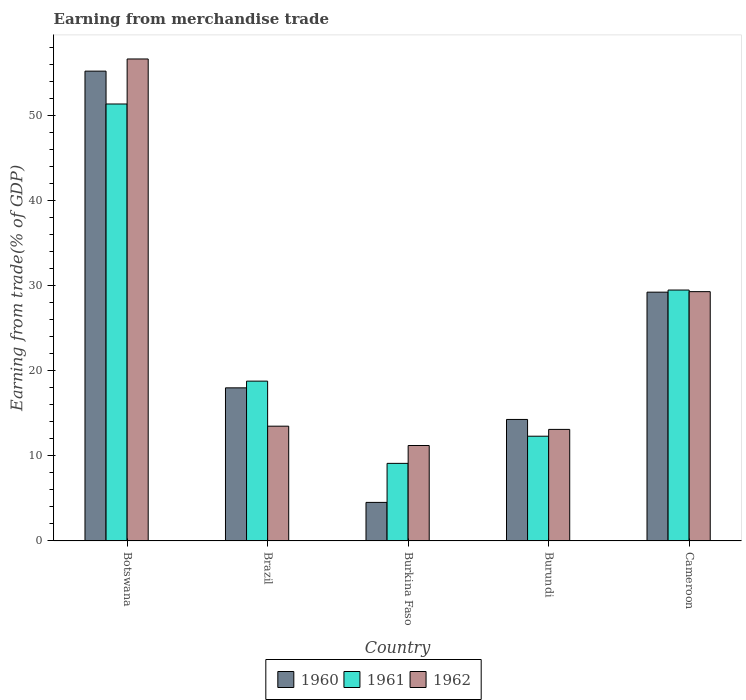Are the number of bars per tick equal to the number of legend labels?
Your answer should be compact. Yes. What is the label of the 2nd group of bars from the left?
Provide a short and direct response. Brazil. What is the earnings from trade in 1961 in Brazil?
Ensure brevity in your answer.  18.79. Across all countries, what is the maximum earnings from trade in 1962?
Keep it short and to the point. 56.67. Across all countries, what is the minimum earnings from trade in 1962?
Offer a very short reply. 11.22. In which country was the earnings from trade in 1960 maximum?
Keep it short and to the point. Botswana. In which country was the earnings from trade in 1961 minimum?
Offer a very short reply. Burkina Faso. What is the total earnings from trade in 1960 in the graph?
Your answer should be compact. 121.31. What is the difference between the earnings from trade in 1962 in Brazil and that in Burkina Faso?
Provide a succinct answer. 2.27. What is the difference between the earnings from trade in 1961 in Burkina Faso and the earnings from trade in 1960 in Brazil?
Your response must be concise. -8.88. What is the average earnings from trade in 1962 per country?
Ensure brevity in your answer.  24.76. What is the difference between the earnings from trade of/in 1962 and earnings from trade of/in 1960 in Burkina Faso?
Offer a terse response. 6.69. What is the ratio of the earnings from trade in 1962 in Botswana to that in Cameroon?
Your answer should be compact. 1.93. Is the earnings from trade in 1962 in Botswana less than that in Burkina Faso?
Keep it short and to the point. No. What is the difference between the highest and the second highest earnings from trade in 1960?
Give a very brief answer. -11.25. What is the difference between the highest and the lowest earnings from trade in 1961?
Offer a very short reply. 42.26. What does the 3rd bar from the right in Botswana represents?
Make the answer very short. 1960. How many bars are there?
Make the answer very short. 15. How many countries are there in the graph?
Ensure brevity in your answer.  5. Where does the legend appear in the graph?
Offer a terse response. Bottom center. How many legend labels are there?
Offer a terse response. 3. What is the title of the graph?
Provide a succinct answer. Earning from merchandise trade. Does "1996" appear as one of the legend labels in the graph?
Offer a very short reply. No. What is the label or title of the X-axis?
Ensure brevity in your answer.  Country. What is the label or title of the Y-axis?
Your answer should be very brief. Earning from trade(% of GDP). What is the Earning from trade(% of GDP) of 1960 in Botswana?
Your answer should be very brief. 55.24. What is the Earning from trade(% of GDP) in 1961 in Botswana?
Give a very brief answer. 51.38. What is the Earning from trade(% of GDP) of 1962 in Botswana?
Ensure brevity in your answer.  56.67. What is the Earning from trade(% of GDP) of 1960 in Brazil?
Offer a terse response. 18. What is the Earning from trade(% of GDP) in 1961 in Brazil?
Your response must be concise. 18.79. What is the Earning from trade(% of GDP) of 1962 in Brazil?
Your answer should be compact. 13.49. What is the Earning from trade(% of GDP) in 1960 in Burkina Faso?
Offer a terse response. 4.53. What is the Earning from trade(% of GDP) of 1961 in Burkina Faso?
Your answer should be very brief. 9.12. What is the Earning from trade(% of GDP) in 1962 in Burkina Faso?
Offer a very short reply. 11.22. What is the Earning from trade(% of GDP) in 1960 in Burundi?
Provide a succinct answer. 14.29. What is the Earning from trade(% of GDP) of 1961 in Burundi?
Your response must be concise. 12.32. What is the Earning from trade(% of GDP) in 1962 in Burundi?
Provide a short and direct response. 13.11. What is the Earning from trade(% of GDP) in 1960 in Cameroon?
Offer a terse response. 29.25. What is the Earning from trade(% of GDP) in 1961 in Cameroon?
Offer a very short reply. 29.5. What is the Earning from trade(% of GDP) in 1962 in Cameroon?
Give a very brief answer. 29.31. Across all countries, what is the maximum Earning from trade(% of GDP) of 1960?
Give a very brief answer. 55.24. Across all countries, what is the maximum Earning from trade(% of GDP) of 1961?
Your answer should be compact. 51.38. Across all countries, what is the maximum Earning from trade(% of GDP) in 1962?
Keep it short and to the point. 56.67. Across all countries, what is the minimum Earning from trade(% of GDP) of 1960?
Provide a succinct answer. 4.53. Across all countries, what is the minimum Earning from trade(% of GDP) in 1961?
Offer a terse response. 9.12. Across all countries, what is the minimum Earning from trade(% of GDP) in 1962?
Give a very brief answer. 11.22. What is the total Earning from trade(% of GDP) of 1960 in the graph?
Your answer should be very brief. 121.31. What is the total Earning from trade(% of GDP) in 1961 in the graph?
Your answer should be compact. 121.11. What is the total Earning from trade(% of GDP) of 1962 in the graph?
Offer a terse response. 123.81. What is the difference between the Earning from trade(% of GDP) in 1960 in Botswana and that in Brazil?
Provide a short and direct response. 37.24. What is the difference between the Earning from trade(% of GDP) of 1961 in Botswana and that in Brazil?
Provide a succinct answer. 32.59. What is the difference between the Earning from trade(% of GDP) of 1962 in Botswana and that in Brazil?
Offer a terse response. 43.18. What is the difference between the Earning from trade(% of GDP) in 1960 in Botswana and that in Burkina Faso?
Your answer should be compact. 50.71. What is the difference between the Earning from trade(% of GDP) of 1961 in Botswana and that in Burkina Faso?
Give a very brief answer. 42.26. What is the difference between the Earning from trade(% of GDP) of 1962 in Botswana and that in Burkina Faso?
Provide a short and direct response. 45.45. What is the difference between the Earning from trade(% of GDP) of 1960 in Botswana and that in Burundi?
Provide a succinct answer. 40.96. What is the difference between the Earning from trade(% of GDP) in 1961 in Botswana and that in Burundi?
Provide a succinct answer. 39.06. What is the difference between the Earning from trade(% of GDP) in 1962 in Botswana and that in Burundi?
Ensure brevity in your answer.  43.56. What is the difference between the Earning from trade(% of GDP) in 1960 in Botswana and that in Cameroon?
Offer a terse response. 25.99. What is the difference between the Earning from trade(% of GDP) in 1961 in Botswana and that in Cameroon?
Provide a succinct answer. 21.88. What is the difference between the Earning from trade(% of GDP) of 1962 in Botswana and that in Cameroon?
Make the answer very short. 27.36. What is the difference between the Earning from trade(% of GDP) of 1960 in Brazil and that in Burkina Faso?
Provide a short and direct response. 13.47. What is the difference between the Earning from trade(% of GDP) of 1961 in Brazil and that in Burkina Faso?
Your answer should be very brief. 9.67. What is the difference between the Earning from trade(% of GDP) of 1962 in Brazil and that in Burkina Faso?
Offer a terse response. 2.27. What is the difference between the Earning from trade(% of GDP) in 1960 in Brazil and that in Burundi?
Your response must be concise. 3.72. What is the difference between the Earning from trade(% of GDP) in 1961 in Brazil and that in Burundi?
Provide a short and direct response. 6.47. What is the difference between the Earning from trade(% of GDP) in 1962 in Brazil and that in Burundi?
Your answer should be very brief. 0.38. What is the difference between the Earning from trade(% of GDP) of 1960 in Brazil and that in Cameroon?
Provide a short and direct response. -11.25. What is the difference between the Earning from trade(% of GDP) in 1961 in Brazil and that in Cameroon?
Give a very brief answer. -10.71. What is the difference between the Earning from trade(% of GDP) of 1962 in Brazil and that in Cameroon?
Provide a succinct answer. -15.82. What is the difference between the Earning from trade(% of GDP) of 1960 in Burkina Faso and that in Burundi?
Keep it short and to the point. -9.75. What is the difference between the Earning from trade(% of GDP) in 1961 in Burkina Faso and that in Burundi?
Your response must be concise. -3.19. What is the difference between the Earning from trade(% of GDP) of 1962 in Burkina Faso and that in Burundi?
Your response must be concise. -1.89. What is the difference between the Earning from trade(% of GDP) in 1960 in Burkina Faso and that in Cameroon?
Your answer should be very brief. -24.72. What is the difference between the Earning from trade(% of GDP) of 1961 in Burkina Faso and that in Cameroon?
Make the answer very short. -20.38. What is the difference between the Earning from trade(% of GDP) of 1962 in Burkina Faso and that in Cameroon?
Make the answer very short. -18.09. What is the difference between the Earning from trade(% of GDP) of 1960 in Burundi and that in Cameroon?
Give a very brief answer. -14.97. What is the difference between the Earning from trade(% of GDP) of 1961 in Burundi and that in Cameroon?
Ensure brevity in your answer.  -17.19. What is the difference between the Earning from trade(% of GDP) in 1962 in Burundi and that in Cameroon?
Your response must be concise. -16.2. What is the difference between the Earning from trade(% of GDP) of 1960 in Botswana and the Earning from trade(% of GDP) of 1961 in Brazil?
Offer a terse response. 36.45. What is the difference between the Earning from trade(% of GDP) in 1960 in Botswana and the Earning from trade(% of GDP) in 1962 in Brazil?
Offer a very short reply. 41.75. What is the difference between the Earning from trade(% of GDP) in 1961 in Botswana and the Earning from trade(% of GDP) in 1962 in Brazil?
Provide a short and direct response. 37.88. What is the difference between the Earning from trade(% of GDP) of 1960 in Botswana and the Earning from trade(% of GDP) of 1961 in Burkina Faso?
Offer a very short reply. 46.12. What is the difference between the Earning from trade(% of GDP) in 1960 in Botswana and the Earning from trade(% of GDP) in 1962 in Burkina Faso?
Provide a short and direct response. 44.02. What is the difference between the Earning from trade(% of GDP) in 1961 in Botswana and the Earning from trade(% of GDP) in 1962 in Burkina Faso?
Offer a very short reply. 40.16. What is the difference between the Earning from trade(% of GDP) in 1960 in Botswana and the Earning from trade(% of GDP) in 1961 in Burundi?
Your answer should be compact. 42.93. What is the difference between the Earning from trade(% of GDP) of 1960 in Botswana and the Earning from trade(% of GDP) of 1962 in Burundi?
Your response must be concise. 42.13. What is the difference between the Earning from trade(% of GDP) in 1961 in Botswana and the Earning from trade(% of GDP) in 1962 in Burundi?
Your answer should be compact. 38.26. What is the difference between the Earning from trade(% of GDP) of 1960 in Botswana and the Earning from trade(% of GDP) of 1961 in Cameroon?
Offer a very short reply. 25.74. What is the difference between the Earning from trade(% of GDP) of 1960 in Botswana and the Earning from trade(% of GDP) of 1962 in Cameroon?
Provide a short and direct response. 25.93. What is the difference between the Earning from trade(% of GDP) of 1961 in Botswana and the Earning from trade(% of GDP) of 1962 in Cameroon?
Keep it short and to the point. 22.07. What is the difference between the Earning from trade(% of GDP) of 1960 in Brazil and the Earning from trade(% of GDP) of 1961 in Burkina Faso?
Give a very brief answer. 8.88. What is the difference between the Earning from trade(% of GDP) of 1960 in Brazil and the Earning from trade(% of GDP) of 1962 in Burkina Faso?
Your answer should be very brief. 6.78. What is the difference between the Earning from trade(% of GDP) of 1961 in Brazil and the Earning from trade(% of GDP) of 1962 in Burkina Faso?
Offer a terse response. 7.57. What is the difference between the Earning from trade(% of GDP) of 1960 in Brazil and the Earning from trade(% of GDP) of 1961 in Burundi?
Give a very brief answer. 5.69. What is the difference between the Earning from trade(% of GDP) of 1960 in Brazil and the Earning from trade(% of GDP) of 1962 in Burundi?
Offer a terse response. 4.89. What is the difference between the Earning from trade(% of GDP) of 1961 in Brazil and the Earning from trade(% of GDP) of 1962 in Burundi?
Make the answer very short. 5.68. What is the difference between the Earning from trade(% of GDP) in 1960 in Brazil and the Earning from trade(% of GDP) in 1962 in Cameroon?
Ensure brevity in your answer.  -11.31. What is the difference between the Earning from trade(% of GDP) in 1961 in Brazil and the Earning from trade(% of GDP) in 1962 in Cameroon?
Keep it short and to the point. -10.52. What is the difference between the Earning from trade(% of GDP) in 1960 in Burkina Faso and the Earning from trade(% of GDP) in 1961 in Burundi?
Offer a terse response. -7.78. What is the difference between the Earning from trade(% of GDP) of 1960 in Burkina Faso and the Earning from trade(% of GDP) of 1962 in Burundi?
Your answer should be very brief. -8.58. What is the difference between the Earning from trade(% of GDP) in 1961 in Burkina Faso and the Earning from trade(% of GDP) in 1962 in Burundi?
Ensure brevity in your answer.  -3.99. What is the difference between the Earning from trade(% of GDP) of 1960 in Burkina Faso and the Earning from trade(% of GDP) of 1961 in Cameroon?
Offer a terse response. -24.97. What is the difference between the Earning from trade(% of GDP) in 1960 in Burkina Faso and the Earning from trade(% of GDP) in 1962 in Cameroon?
Your answer should be compact. -24.78. What is the difference between the Earning from trade(% of GDP) in 1961 in Burkina Faso and the Earning from trade(% of GDP) in 1962 in Cameroon?
Make the answer very short. -20.19. What is the difference between the Earning from trade(% of GDP) of 1960 in Burundi and the Earning from trade(% of GDP) of 1961 in Cameroon?
Keep it short and to the point. -15.22. What is the difference between the Earning from trade(% of GDP) of 1960 in Burundi and the Earning from trade(% of GDP) of 1962 in Cameroon?
Your answer should be very brief. -15.03. What is the difference between the Earning from trade(% of GDP) in 1961 in Burundi and the Earning from trade(% of GDP) in 1962 in Cameroon?
Provide a succinct answer. -17. What is the average Earning from trade(% of GDP) of 1960 per country?
Make the answer very short. 24.26. What is the average Earning from trade(% of GDP) in 1961 per country?
Provide a short and direct response. 24.22. What is the average Earning from trade(% of GDP) in 1962 per country?
Provide a succinct answer. 24.76. What is the difference between the Earning from trade(% of GDP) of 1960 and Earning from trade(% of GDP) of 1961 in Botswana?
Give a very brief answer. 3.86. What is the difference between the Earning from trade(% of GDP) of 1960 and Earning from trade(% of GDP) of 1962 in Botswana?
Provide a short and direct response. -1.43. What is the difference between the Earning from trade(% of GDP) in 1961 and Earning from trade(% of GDP) in 1962 in Botswana?
Ensure brevity in your answer.  -5.29. What is the difference between the Earning from trade(% of GDP) of 1960 and Earning from trade(% of GDP) of 1961 in Brazil?
Your answer should be very brief. -0.79. What is the difference between the Earning from trade(% of GDP) in 1960 and Earning from trade(% of GDP) in 1962 in Brazil?
Your answer should be compact. 4.51. What is the difference between the Earning from trade(% of GDP) of 1961 and Earning from trade(% of GDP) of 1962 in Brazil?
Give a very brief answer. 5.3. What is the difference between the Earning from trade(% of GDP) of 1960 and Earning from trade(% of GDP) of 1961 in Burkina Faso?
Provide a succinct answer. -4.59. What is the difference between the Earning from trade(% of GDP) in 1960 and Earning from trade(% of GDP) in 1962 in Burkina Faso?
Offer a terse response. -6.69. What is the difference between the Earning from trade(% of GDP) of 1961 and Earning from trade(% of GDP) of 1962 in Burkina Faso?
Your answer should be compact. -2.1. What is the difference between the Earning from trade(% of GDP) in 1960 and Earning from trade(% of GDP) in 1961 in Burundi?
Offer a terse response. 1.97. What is the difference between the Earning from trade(% of GDP) in 1960 and Earning from trade(% of GDP) in 1962 in Burundi?
Keep it short and to the point. 1.17. What is the difference between the Earning from trade(% of GDP) of 1961 and Earning from trade(% of GDP) of 1962 in Burundi?
Your response must be concise. -0.8. What is the difference between the Earning from trade(% of GDP) in 1960 and Earning from trade(% of GDP) in 1961 in Cameroon?
Your answer should be very brief. -0.25. What is the difference between the Earning from trade(% of GDP) of 1960 and Earning from trade(% of GDP) of 1962 in Cameroon?
Keep it short and to the point. -0.06. What is the difference between the Earning from trade(% of GDP) of 1961 and Earning from trade(% of GDP) of 1962 in Cameroon?
Keep it short and to the point. 0.19. What is the ratio of the Earning from trade(% of GDP) of 1960 in Botswana to that in Brazil?
Your answer should be compact. 3.07. What is the ratio of the Earning from trade(% of GDP) of 1961 in Botswana to that in Brazil?
Your answer should be very brief. 2.73. What is the ratio of the Earning from trade(% of GDP) in 1962 in Botswana to that in Brazil?
Provide a succinct answer. 4.2. What is the ratio of the Earning from trade(% of GDP) in 1960 in Botswana to that in Burkina Faso?
Your response must be concise. 12.19. What is the ratio of the Earning from trade(% of GDP) of 1961 in Botswana to that in Burkina Faso?
Provide a succinct answer. 5.63. What is the ratio of the Earning from trade(% of GDP) in 1962 in Botswana to that in Burkina Faso?
Your answer should be very brief. 5.05. What is the ratio of the Earning from trade(% of GDP) in 1960 in Botswana to that in Burundi?
Provide a short and direct response. 3.87. What is the ratio of the Earning from trade(% of GDP) in 1961 in Botswana to that in Burundi?
Give a very brief answer. 4.17. What is the ratio of the Earning from trade(% of GDP) of 1962 in Botswana to that in Burundi?
Give a very brief answer. 4.32. What is the ratio of the Earning from trade(% of GDP) of 1960 in Botswana to that in Cameroon?
Keep it short and to the point. 1.89. What is the ratio of the Earning from trade(% of GDP) in 1961 in Botswana to that in Cameroon?
Your answer should be very brief. 1.74. What is the ratio of the Earning from trade(% of GDP) of 1962 in Botswana to that in Cameroon?
Your answer should be very brief. 1.93. What is the ratio of the Earning from trade(% of GDP) of 1960 in Brazil to that in Burkina Faso?
Provide a short and direct response. 3.97. What is the ratio of the Earning from trade(% of GDP) of 1961 in Brazil to that in Burkina Faso?
Offer a terse response. 2.06. What is the ratio of the Earning from trade(% of GDP) in 1962 in Brazil to that in Burkina Faso?
Your answer should be compact. 1.2. What is the ratio of the Earning from trade(% of GDP) in 1960 in Brazil to that in Burundi?
Offer a terse response. 1.26. What is the ratio of the Earning from trade(% of GDP) in 1961 in Brazil to that in Burundi?
Offer a terse response. 1.53. What is the ratio of the Earning from trade(% of GDP) of 1962 in Brazil to that in Burundi?
Offer a very short reply. 1.03. What is the ratio of the Earning from trade(% of GDP) in 1960 in Brazil to that in Cameroon?
Your answer should be compact. 0.62. What is the ratio of the Earning from trade(% of GDP) in 1961 in Brazil to that in Cameroon?
Provide a succinct answer. 0.64. What is the ratio of the Earning from trade(% of GDP) in 1962 in Brazil to that in Cameroon?
Your answer should be compact. 0.46. What is the ratio of the Earning from trade(% of GDP) of 1960 in Burkina Faso to that in Burundi?
Your answer should be very brief. 0.32. What is the ratio of the Earning from trade(% of GDP) of 1961 in Burkina Faso to that in Burundi?
Keep it short and to the point. 0.74. What is the ratio of the Earning from trade(% of GDP) in 1962 in Burkina Faso to that in Burundi?
Offer a terse response. 0.86. What is the ratio of the Earning from trade(% of GDP) of 1960 in Burkina Faso to that in Cameroon?
Provide a succinct answer. 0.15. What is the ratio of the Earning from trade(% of GDP) in 1961 in Burkina Faso to that in Cameroon?
Your answer should be very brief. 0.31. What is the ratio of the Earning from trade(% of GDP) of 1962 in Burkina Faso to that in Cameroon?
Make the answer very short. 0.38. What is the ratio of the Earning from trade(% of GDP) in 1960 in Burundi to that in Cameroon?
Offer a very short reply. 0.49. What is the ratio of the Earning from trade(% of GDP) of 1961 in Burundi to that in Cameroon?
Your answer should be compact. 0.42. What is the ratio of the Earning from trade(% of GDP) in 1962 in Burundi to that in Cameroon?
Keep it short and to the point. 0.45. What is the difference between the highest and the second highest Earning from trade(% of GDP) of 1960?
Keep it short and to the point. 25.99. What is the difference between the highest and the second highest Earning from trade(% of GDP) of 1961?
Ensure brevity in your answer.  21.88. What is the difference between the highest and the second highest Earning from trade(% of GDP) in 1962?
Provide a short and direct response. 27.36. What is the difference between the highest and the lowest Earning from trade(% of GDP) in 1960?
Make the answer very short. 50.71. What is the difference between the highest and the lowest Earning from trade(% of GDP) of 1961?
Give a very brief answer. 42.26. What is the difference between the highest and the lowest Earning from trade(% of GDP) of 1962?
Make the answer very short. 45.45. 